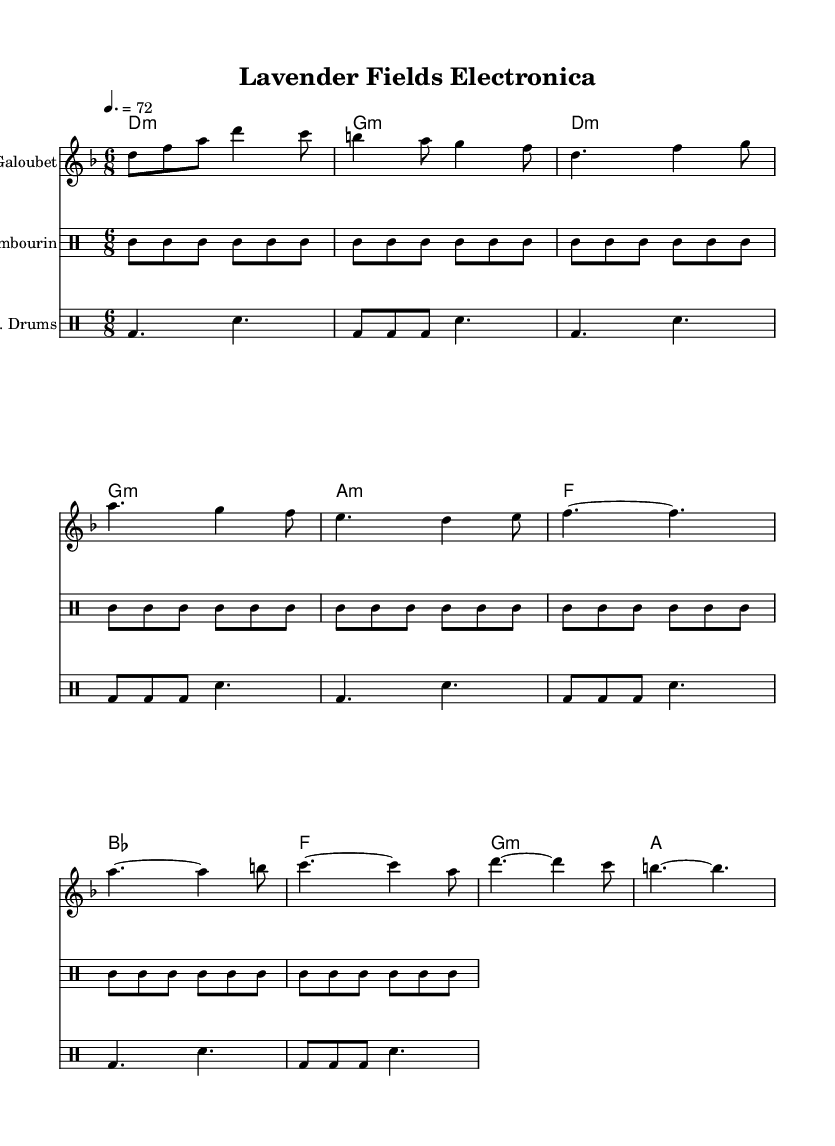What is the key signature of this music? The key signature is D minor, which has one flat (B flat) in the signature. This can be identified at the beginning of the staff beside the clef.
Answer: D minor What is the time signature of this music? The time signature is 6/8, which means there are six eighth notes in each measure. This is indicated at the beginning of the score right after the key signature.
Answer: 6/8 What is the tempo marking for this piece? The tempo marking is quarter note = 72, which indicates that the beats should be held at a speed of 72 quarter notes per minute. This is noted below the title at the beginning of the score.
Answer: 72 How many measures are in the verse section? The verse section consists of four measures. By counting the measures from the beginning of the verse until the end, you can determine the total number.
Answer: 4 What instruments are used in the ensemble? The ensemble includes a Galoubet, a Tambourin, and electronic drums. Each instrument is labeled clearly at the beginning of its respective staff in the score.
Answer: Galoubet, Tambourin, electronic drums Which section has the most varied rhythm? The chorus section has the most varied rhythm as it contains repetitions of different rhythms and notes, making it stand out compared to the more consistent verse and intro sections. This can be deduced by analyzing the rhythmic notation in the chorus.
Answer: Chorus What chord progression is used in the introduction? The chord progression in the introduction is D minor to G minor. This can be determined by looking at the chord symbols written above the staff at the beginning of the piece.
Answer: D minor, G minor 